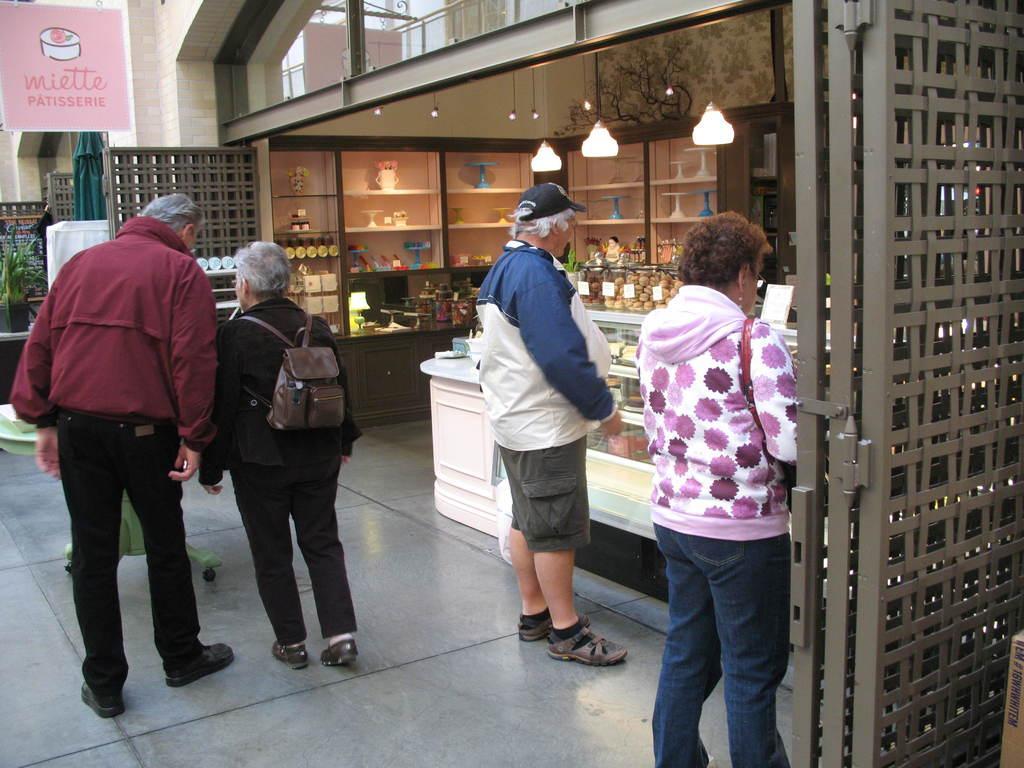Can you describe this image briefly? In this image a man and woman are walking in the path, in background a woman and man are waiting near the shop. 